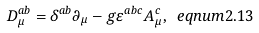Convert formula to latex. <formula><loc_0><loc_0><loc_500><loc_500>D _ { \mu } ^ { a b } = \delta ^ { a b } \partial _ { \mu } - g \varepsilon ^ { a b c } A _ { \mu } ^ { c } , \ e q n u m { 2 . 1 3 }</formula> 